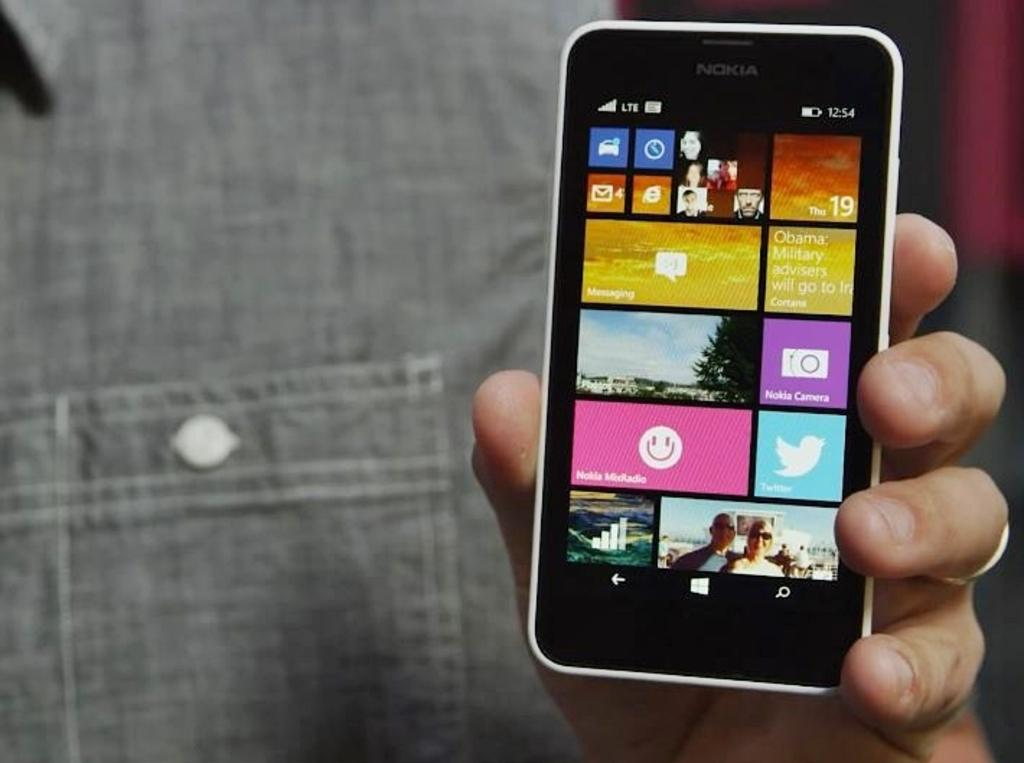What is the main subject of the image? There is a person in the image. What is the person holding in the image? The person is holding a mobile phone. What else can be seen in the image besides the person and the mobile phone? There is a screen visible in the image. How many cats are swimming in the image? There are no cats or swimming activity present in the image. What type of story is being told on the screen in the image? The image does not provide any information about a story being told on the screen; it only shows that a screen is visible. 